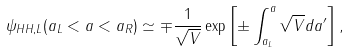<formula> <loc_0><loc_0><loc_500><loc_500>\psi _ { H H , L } ( a _ { L } < a < a _ { R } ) \simeq \mp \frac { 1 } { \sqrt { V } } \exp \left [ \pm \int _ { a _ { L } } ^ { a } \sqrt { V } d a ^ { \prime } \right ] ,</formula> 